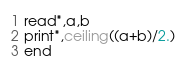Convert code to text. <code><loc_0><loc_0><loc_500><loc_500><_FORTRAN_>read*,a,b
print*,ceiling((a+b)/2.)
end
</code> 